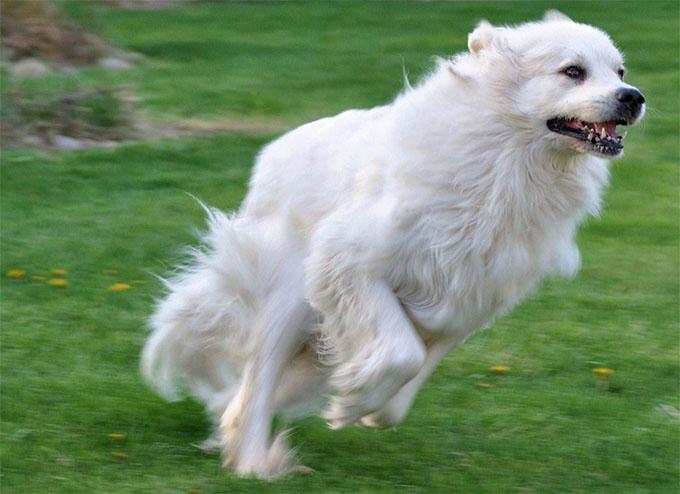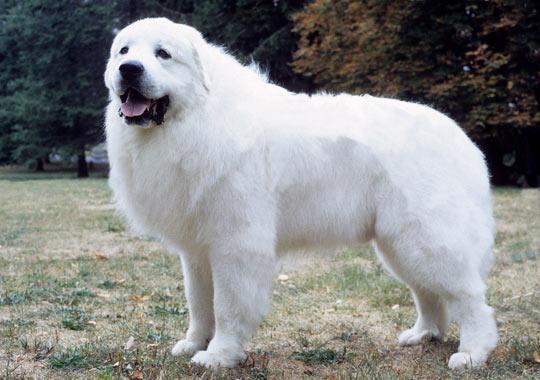The first image is the image on the left, the second image is the image on the right. For the images displayed, is the sentence "One image contains more than one dog." factually correct? Answer yes or no. No. The first image is the image on the left, the second image is the image on the right. Considering the images on both sides, is "There are no more than two dogs." valid? Answer yes or no. Yes. The first image is the image on the left, the second image is the image on the right. Considering the images on both sides, is "A single dog is posing in a grassy area in the image on the left." valid? Answer yes or no. Yes. The first image is the image on the left, the second image is the image on the right. Considering the images on both sides, is "An image shows a white dog with body turned leftward, standing on all fours on a hard floor." valid? Answer yes or no. No. 